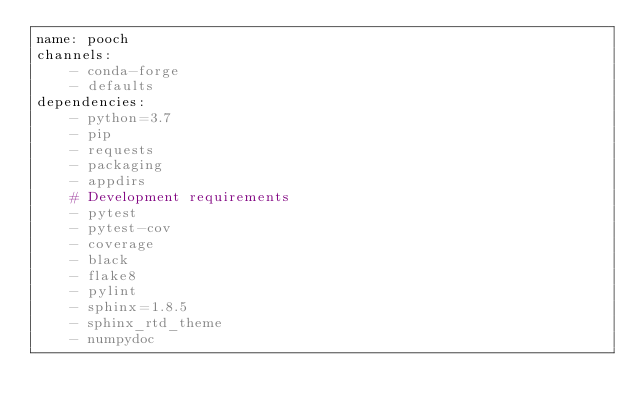Convert code to text. <code><loc_0><loc_0><loc_500><loc_500><_YAML_>name: pooch
channels:
    - conda-forge
    - defaults
dependencies:
    - python=3.7
    - pip
    - requests
    - packaging
    - appdirs
    # Development requirements
    - pytest
    - pytest-cov
    - coverage
    - black
    - flake8
    - pylint
    - sphinx=1.8.5
    - sphinx_rtd_theme
    - numpydoc
</code> 